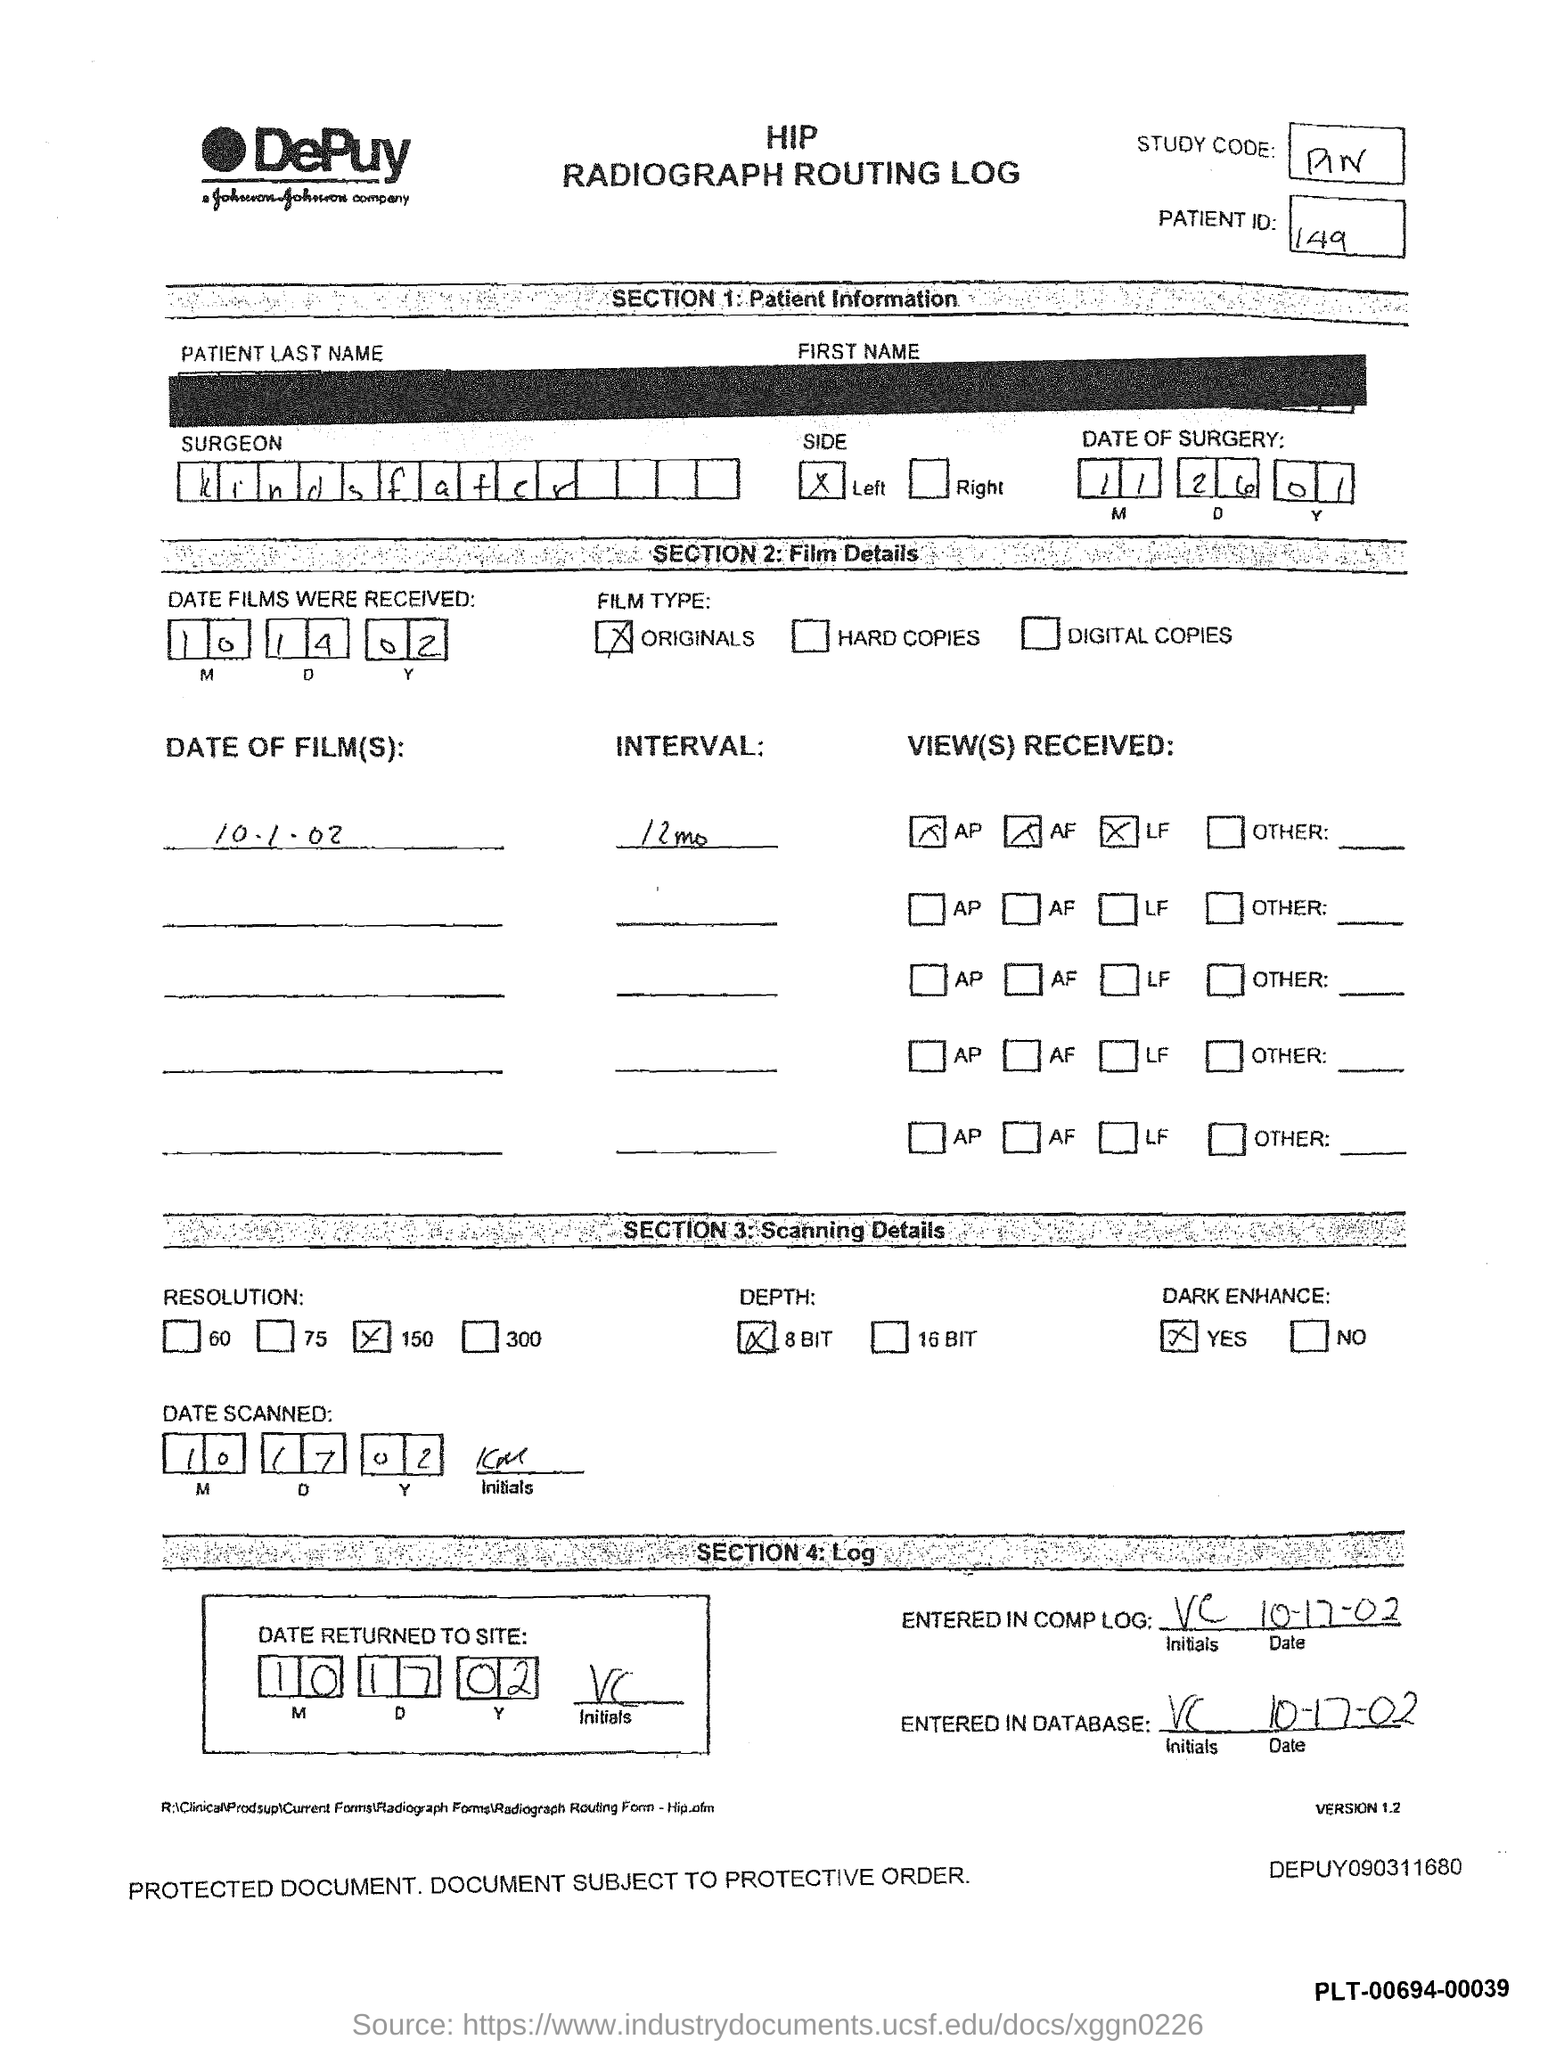What is the patient ID mentioned in the Hip radiography routing log?
Ensure brevity in your answer.  149. What is the name of the surgeon given in the Hip radiography routing log?
Your response must be concise. Kindsfater. What is the date of the surgery mentioned in the Hip radiography routing log?
Provide a succinct answer. 11 26 01. What is the date on which the films were received?
Keep it short and to the point. 10 14 02. 